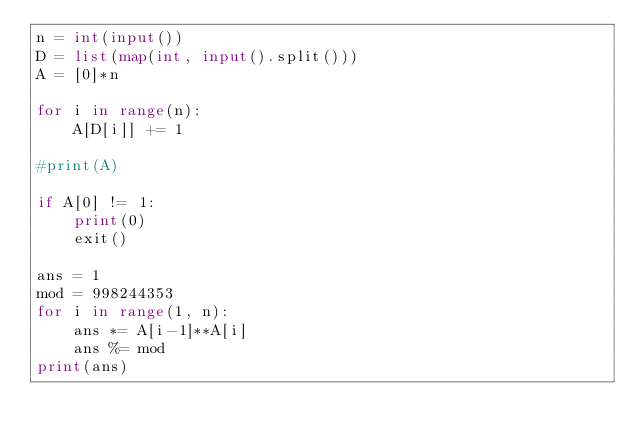Convert code to text. <code><loc_0><loc_0><loc_500><loc_500><_Python_>n = int(input())
D = list(map(int, input().split()))
A = [0]*n

for i in range(n):
    A[D[i]] += 1

#print(A)

if A[0] != 1:
    print(0)
    exit()

ans = 1
mod = 998244353
for i in range(1, n):
    ans *= A[i-1]**A[i]
    ans %= mod
print(ans)
</code> 